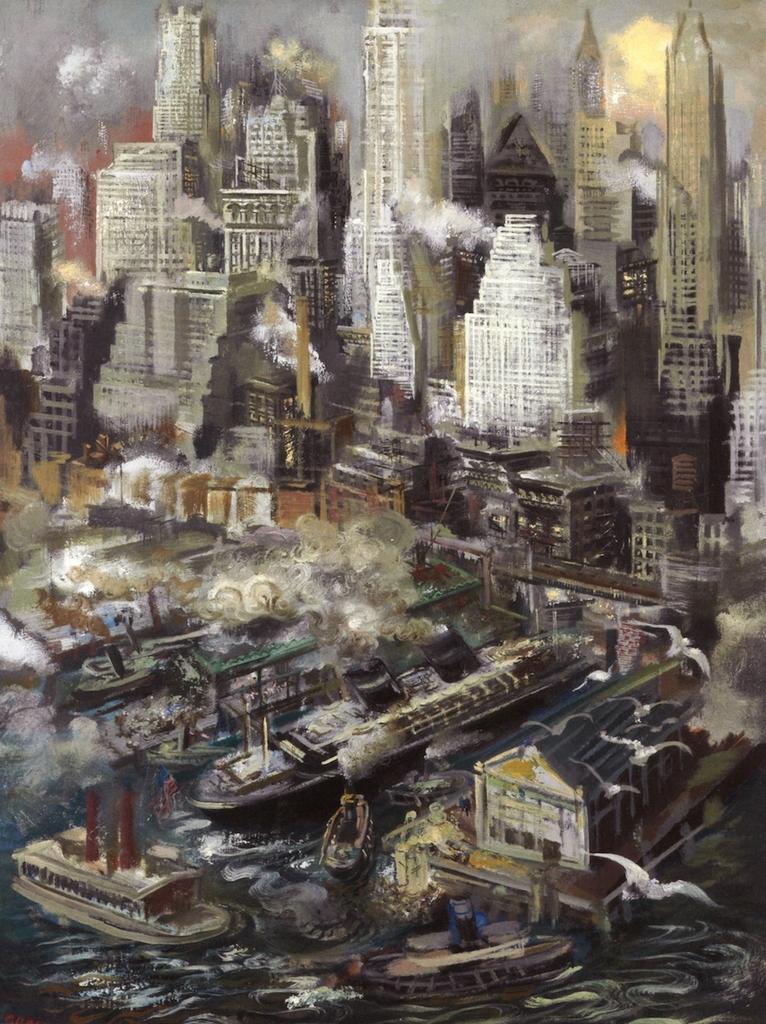Describe this image in one or two sentences. In this image, we can see a painting, there are some buildings and there are some boats and ships. 